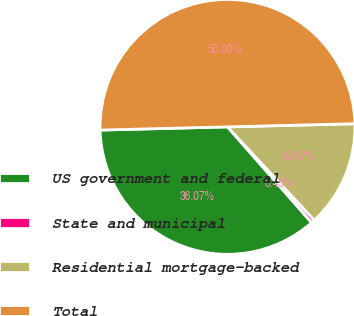Convert chart. <chart><loc_0><loc_0><loc_500><loc_500><pie_chart><fcel>US government and federal<fcel>State and municipal<fcel>Residential mortgage-backed<fcel>Total<nl><fcel>36.07%<fcel>0.45%<fcel>13.47%<fcel>50.0%<nl></chart> 